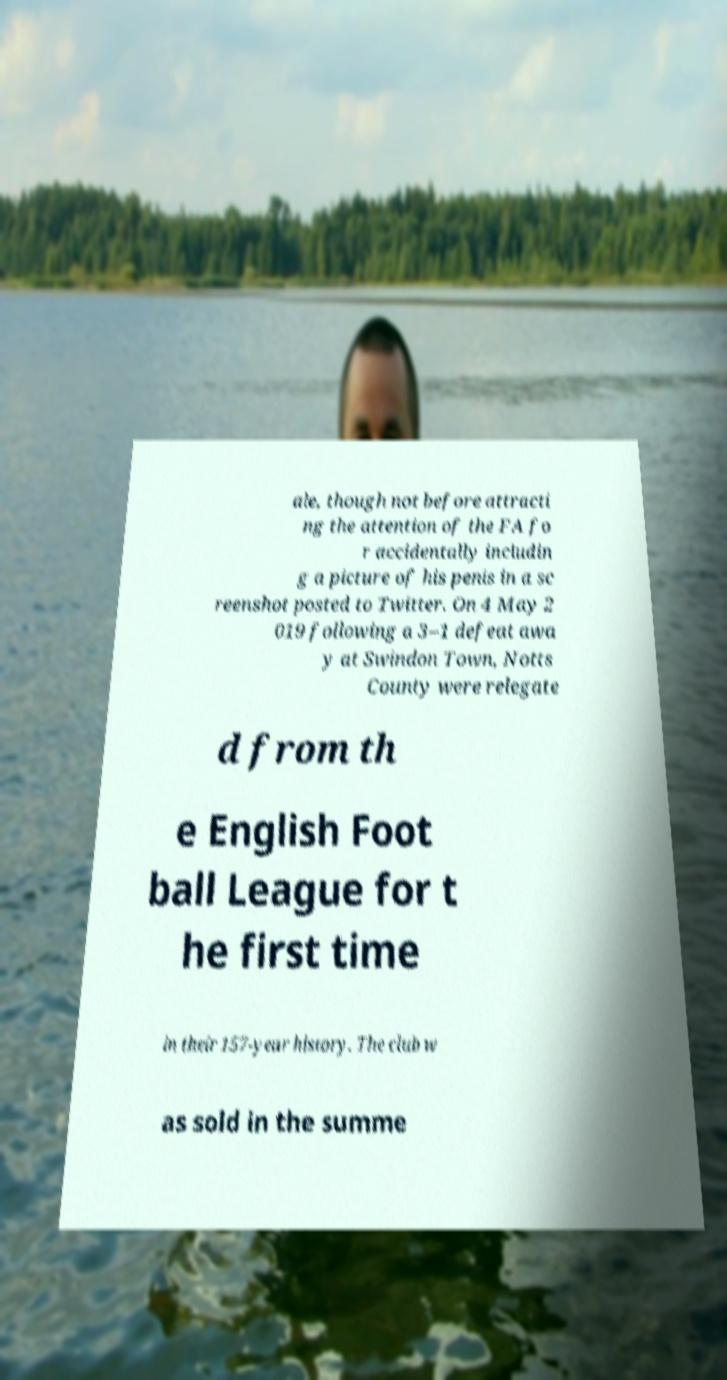There's text embedded in this image that I need extracted. Can you transcribe it verbatim? ale, though not before attracti ng the attention of the FA fo r accidentally includin g a picture of his penis in a sc reenshot posted to Twitter. On 4 May 2 019 following a 3–1 defeat awa y at Swindon Town, Notts County were relegate d from th e English Foot ball League for t he first time in their 157-year history. The club w as sold in the summe 